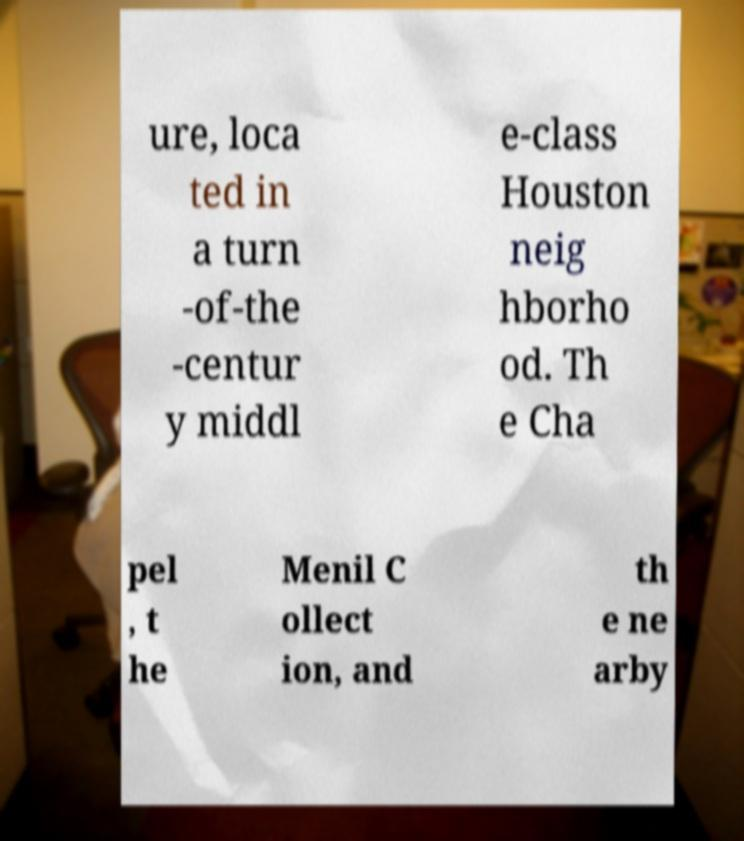What messages or text are displayed in this image? I need them in a readable, typed format. ure, loca ted in a turn -of-the -centur y middl e-class Houston neig hborho od. Th e Cha pel , t he Menil C ollect ion, and th e ne arby 